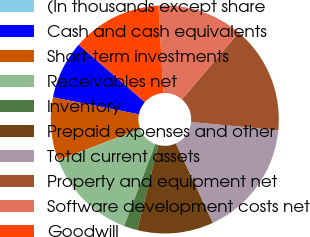Convert chart to OTSL. <chart><loc_0><loc_0><loc_500><loc_500><pie_chart><fcel>(In thousands except share<fcel>Cash and cash equivalents<fcel>Short-term investments<fcel>Receivables net<fcel>Inventory<fcel>Prepaid expenses and other<fcel>Total current assets<fcel>Property and equipment net<fcel>Software development costs net<fcel>Goodwill<nl><fcel>0.0%<fcel>8.28%<fcel>8.92%<fcel>13.38%<fcel>1.91%<fcel>10.83%<fcel>16.56%<fcel>15.29%<fcel>12.1%<fcel>12.74%<nl></chart> 